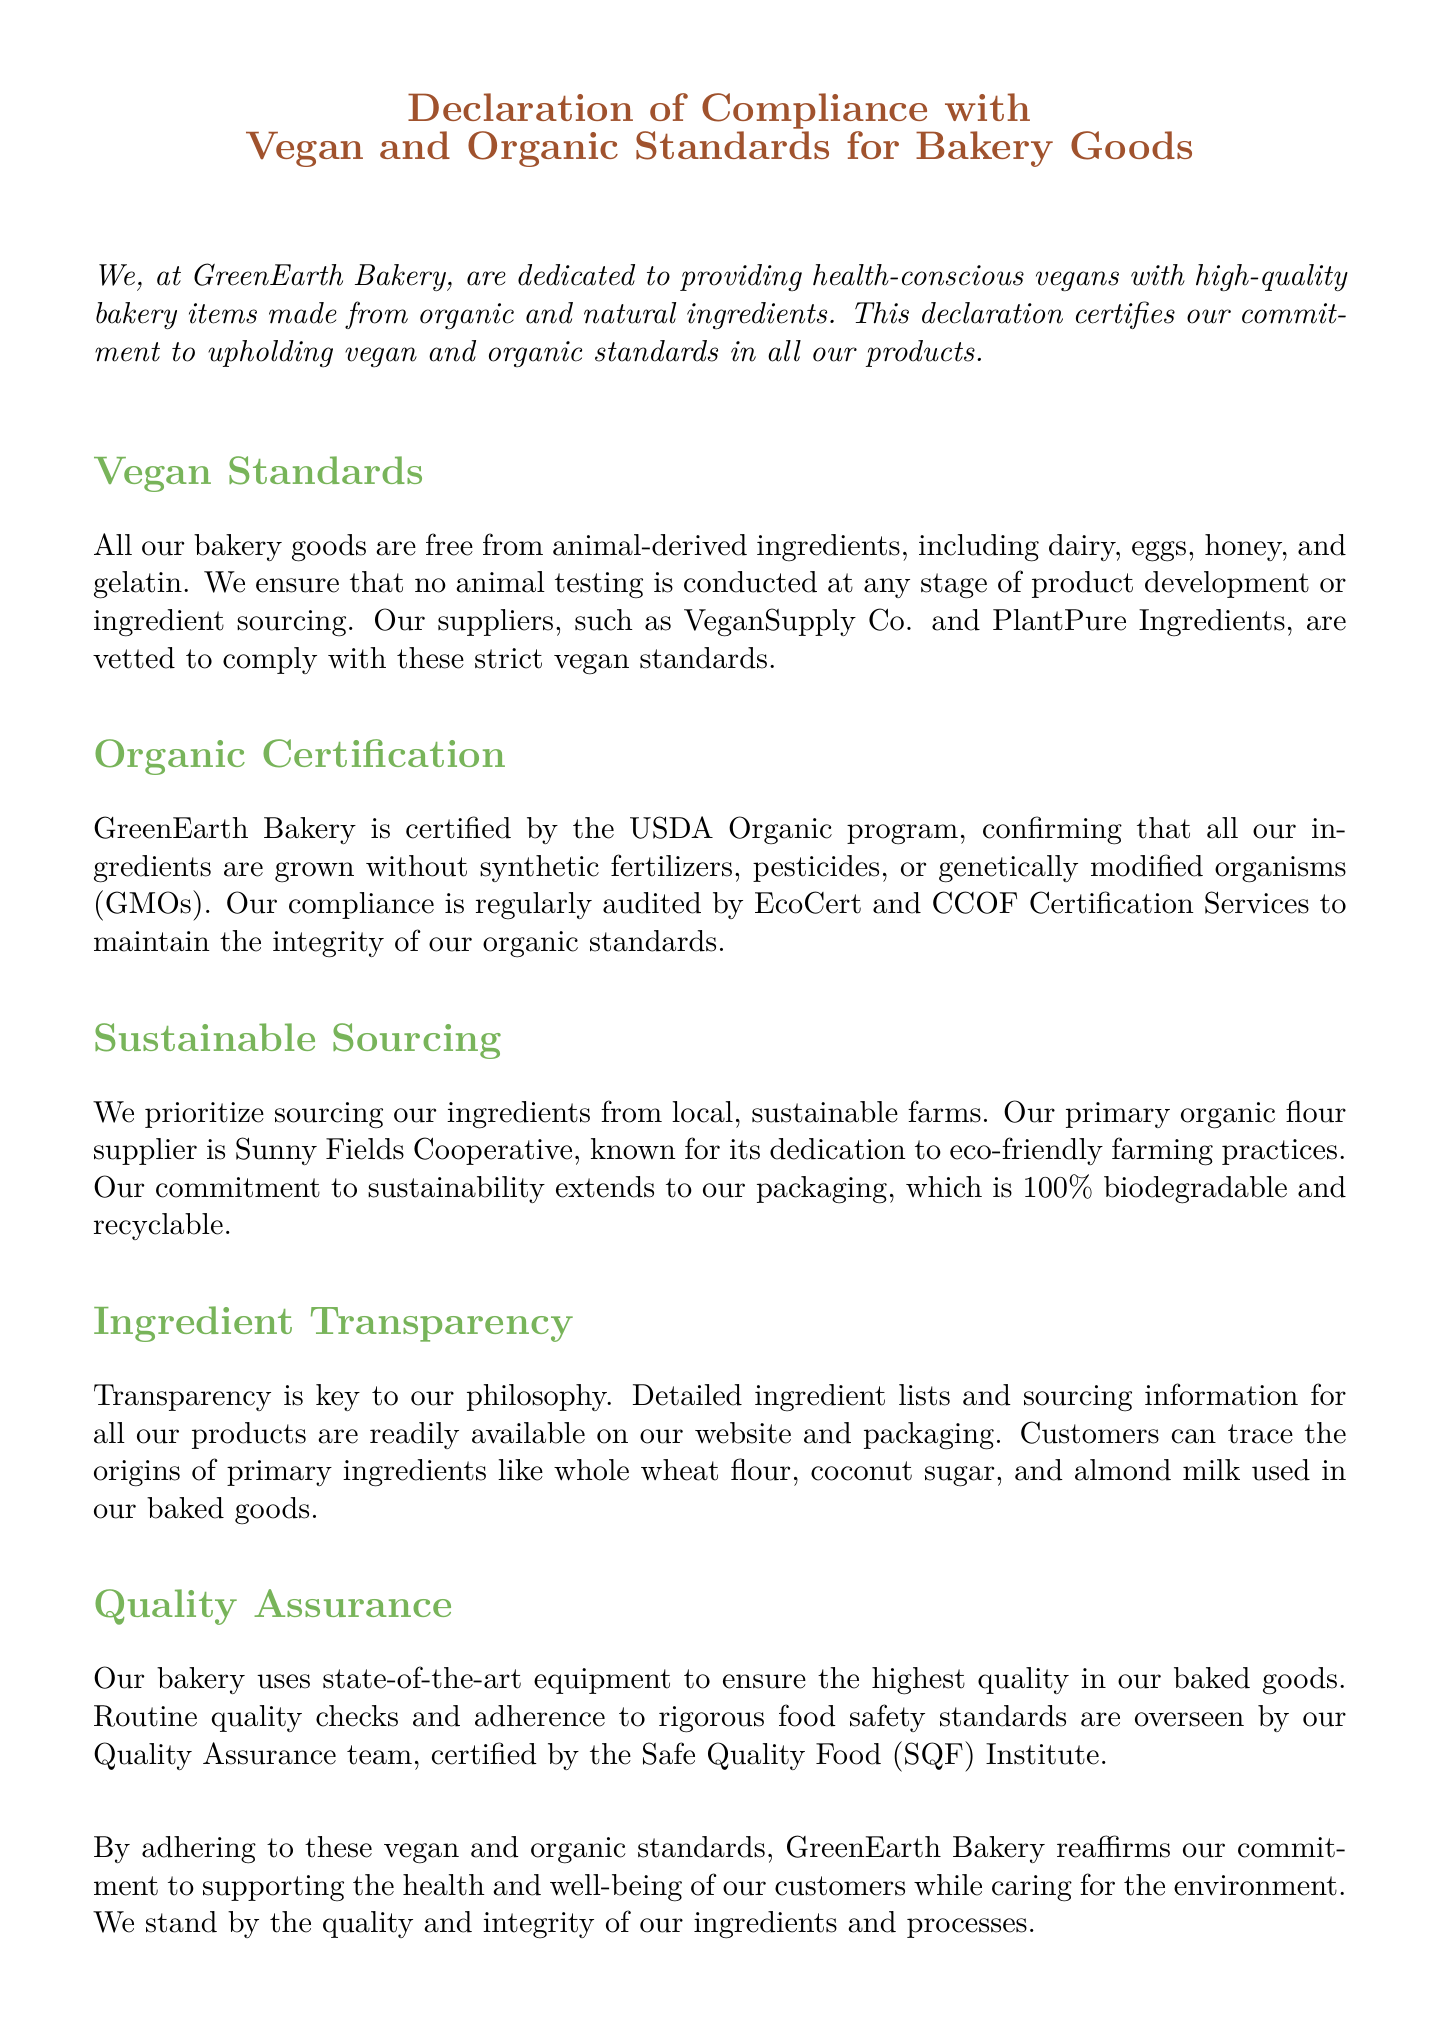What is the name of the bakery? The name of the bakery is prominently mentioned at the beginning of the document.
Answer: GreenEarth Bakery Who is the CEO of GreenEarth Bakery? The CEO is mentioned in the signature line at the bottom of the document.
Answer: John Smith What types of animal-derived ingredients are excluded? The document lists specific animal-derived ingredients that are not used.
Answer: Dairy, eggs, honey, gelatin Which certification confirms the organic status of ingredients? The document specifies which certification is held by GreenEarth Bakery for organic products.
Answer: USDA Organic What is the primary organic flour supplier? The document identifies the key supplier for organic flour.
Answer: Sunny Fields Cooperative Name one of the suppliers that comply with vegan standards. The declaration lists specific suppliers that meet vegan standards.
Answer: VeganSupply Co How often is compliance with organic standards audited? The frequency of audits is indicated in relation to the certification process.
Answer: Regularly What type of packaging does GreenEarth Bakery use? The document describes the nature of the packaging used by the bakery.
Answer: 100% biodegradable and recyclable Which institute certifies the Quality Assurance team? The document specifies the certification body responsible for quality assurance.
Answer: Safe Quality Food (SQF) Institute 